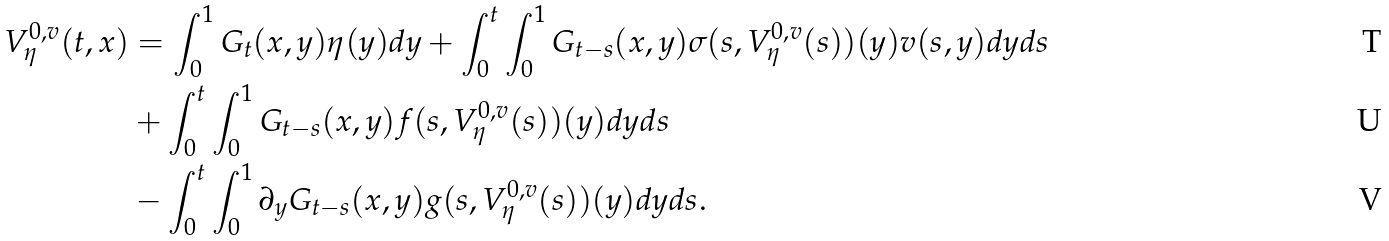Convert formula to latex. <formula><loc_0><loc_0><loc_500><loc_500>V ^ { 0 , v } _ { \eta } ( t , x ) & = \int _ { 0 } ^ { 1 } G _ { t } ( x , y ) \eta ( y ) d y + \int _ { 0 } ^ { t } \int _ { 0 } ^ { 1 } G _ { t - s } ( x , y ) \sigma ( s , V ^ { 0 , v } _ { \eta } ( s ) ) ( y ) v ( s , y ) d y d s \\ & + \int _ { 0 } ^ { t } \int _ { 0 } ^ { 1 } G _ { t - s } ( x , y ) f ( s , V ^ { 0 , v } _ { \eta } ( s ) ) ( y ) d y d s \\ & - \int _ { 0 } ^ { t } \int _ { 0 } ^ { 1 } \partial _ { y } G _ { t - s } ( x , y ) g ( s , V ^ { 0 , v } _ { \eta } ( s ) ) ( y ) d y d s .</formula> 